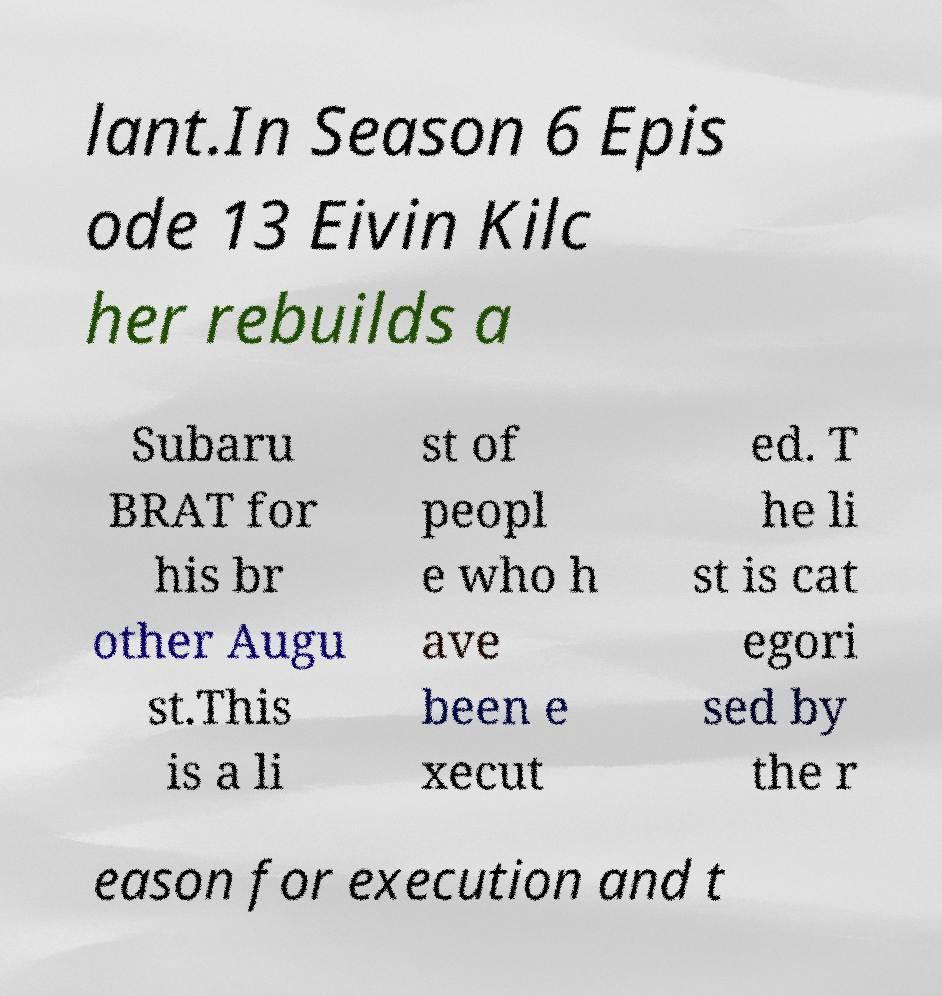For documentation purposes, I need the text within this image transcribed. Could you provide that? lant.In Season 6 Epis ode 13 Eivin Kilc her rebuilds a Subaru BRAT for his br other Augu st.This is a li st of peopl e who h ave been e xecut ed. T he li st is cat egori sed by the r eason for execution and t 